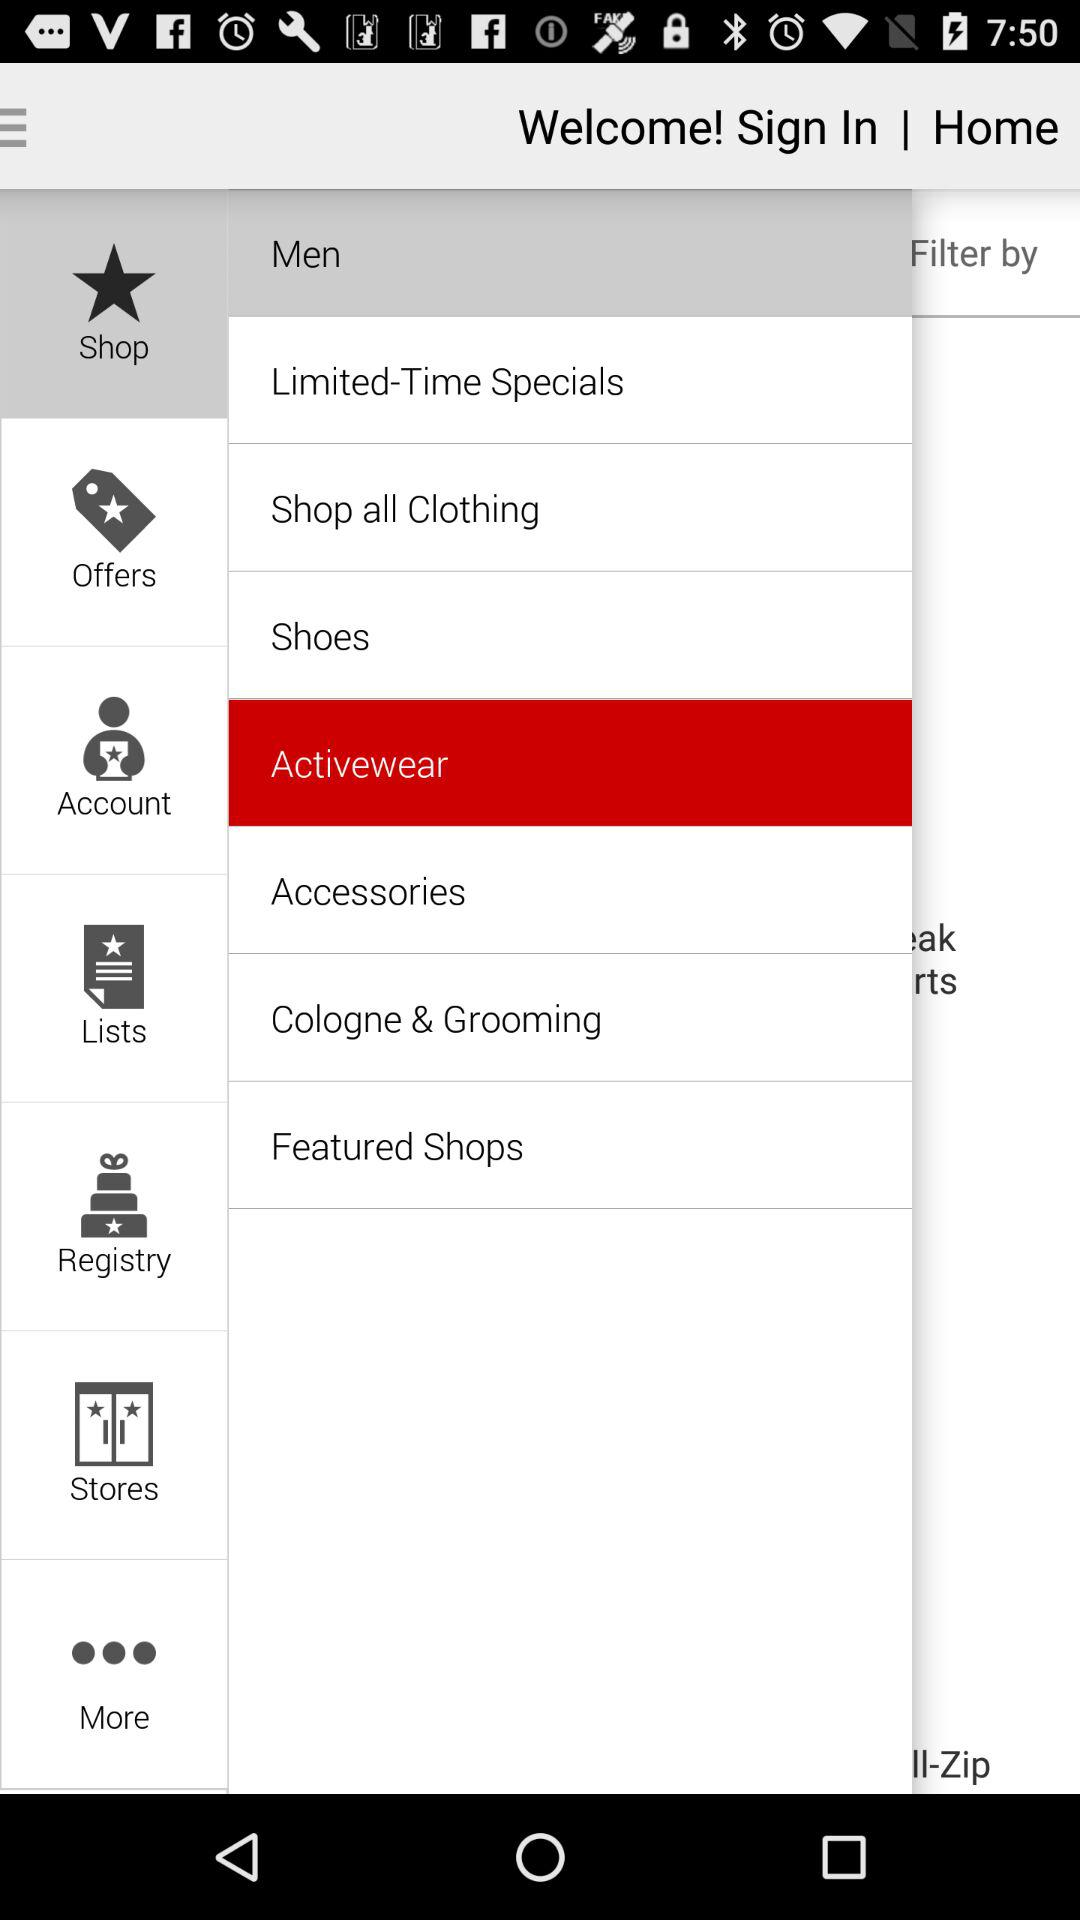Which option is selected in "Shop"? The selected option is "Activewear". 